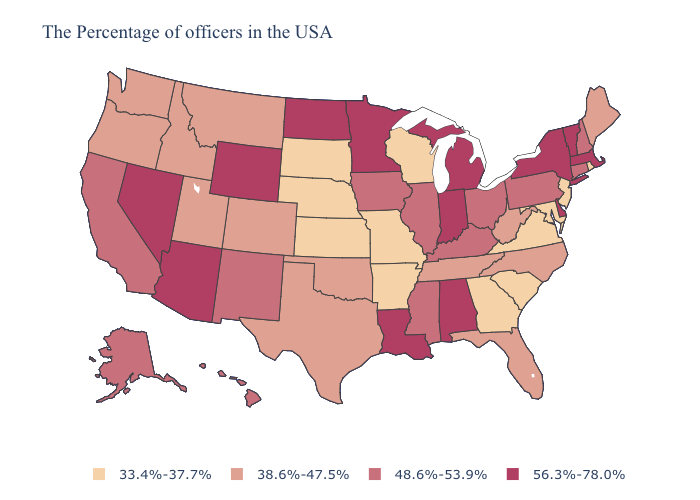What is the value of Pennsylvania?
Quick response, please. 48.6%-53.9%. Which states have the lowest value in the Northeast?
Short answer required. Rhode Island, New Jersey. Does Massachusetts have the lowest value in the Northeast?
Be succinct. No. What is the highest value in the USA?
Quick response, please. 56.3%-78.0%. Which states have the lowest value in the Northeast?
Keep it brief. Rhode Island, New Jersey. What is the value of Delaware?
Keep it brief. 56.3%-78.0%. Does Alabama have the highest value in the South?
Give a very brief answer. Yes. What is the lowest value in the West?
Quick response, please. 38.6%-47.5%. What is the value of Missouri?
Concise answer only. 33.4%-37.7%. Name the states that have a value in the range 48.6%-53.9%?
Quick response, please. New Hampshire, Connecticut, Pennsylvania, Ohio, Kentucky, Illinois, Mississippi, Iowa, New Mexico, California, Alaska, Hawaii. Among the states that border Vermont , which have the lowest value?
Answer briefly. New Hampshire. Does the map have missing data?
Be succinct. No. Name the states that have a value in the range 38.6%-47.5%?
Concise answer only. Maine, North Carolina, West Virginia, Florida, Tennessee, Oklahoma, Texas, Colorado, Utah, Montana, Idaho, Washington, Oregon. What is the lowest value in the USA?
Keep it brief. 33.4%-37.7%. Does Washington have the same value as Massachusetts?
Be succinct. No. 